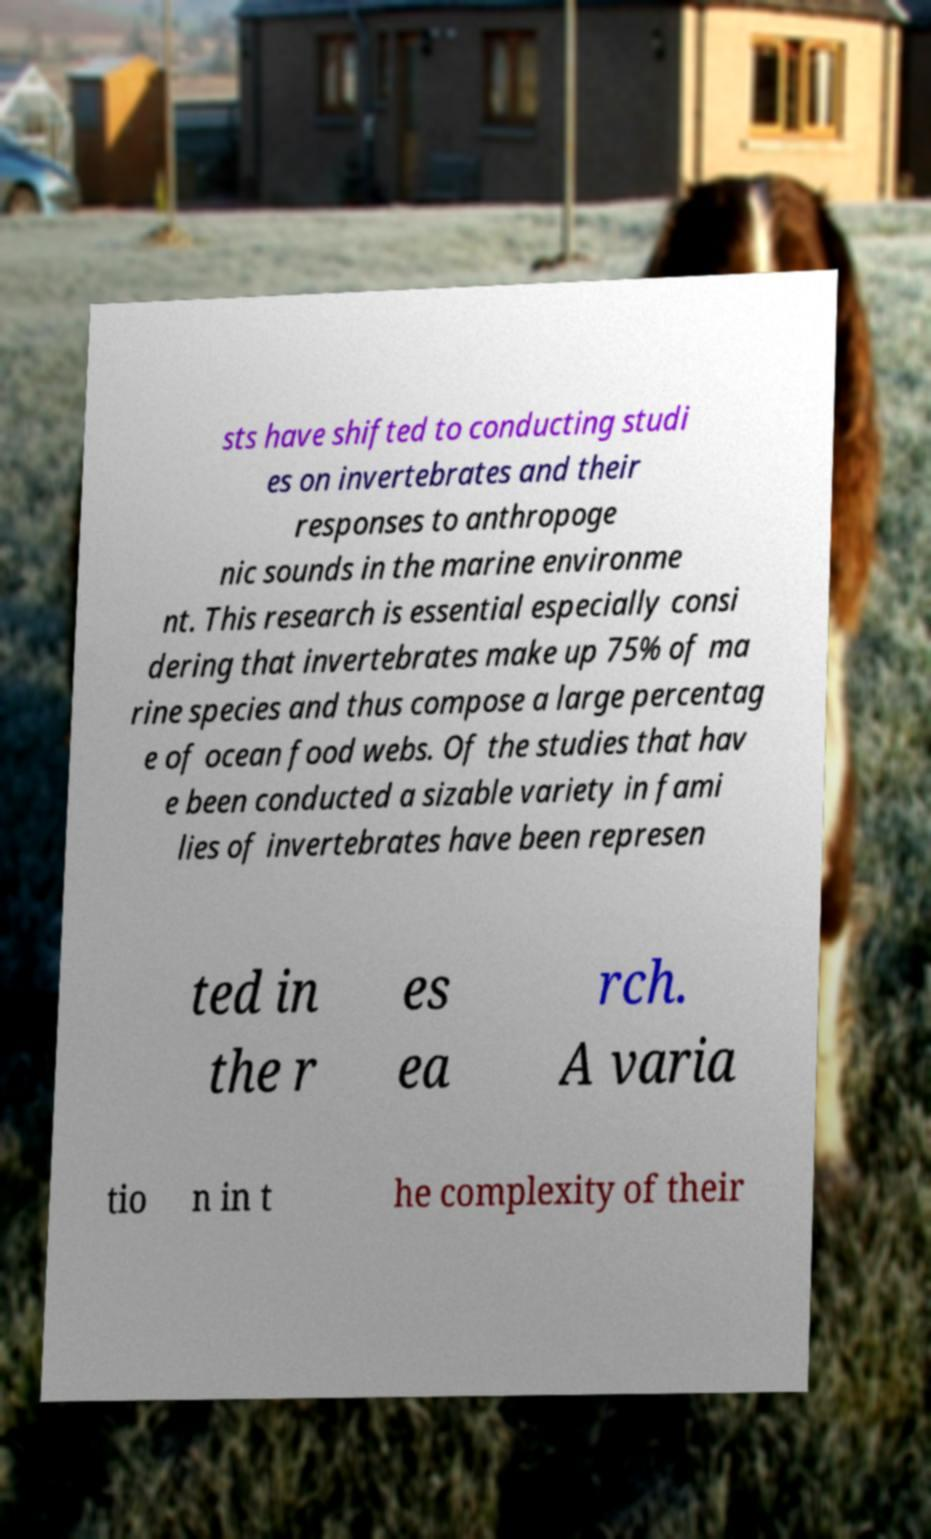For documentation purposes, I need the text within this image transcribed. Could you provide that? sts have shifted to conducting studi es on invertebrates and their responses to anthropoge nic sounds in the marine environme nt. This research is essential especially consi dering that invertebrates make up 75% of ma rine species and thus compose a large percentag e of ocean food webs. Of the studies that hav e been conducted a sizable variety in fami lies of invertebrates have been represen ted in the r es ea rch. A varia tio n in t he complexity of their 